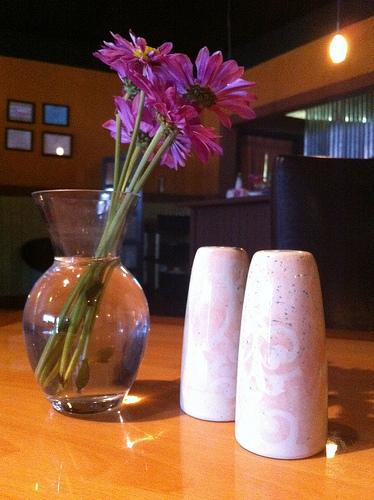List the elements you notice in the image related to the interior design or scenery. Wooden table, clear glass vase, salt and pepper shakers, orange wall, four pictures hanging, and light reflection. In one sentence, tell me what you see in this photograph. A wooden table displays a glass vase with purple flowers and salt and pepper shakers, with four pictures on an orange wall behind. Write a short verse inspired by the scene depicted in this image. Simple beauty, exquisitely expressed. Tell me what the centerpiece of the image consists of. The centerpiece features a glass vase with five purple flowers, green stems, and clear water, placed on a wooden table. Write a brief description of the main items visible in the picture. Purple flowers in a clear vase on a wooden table, salt and pepper shakers, and four pictures hanging on an orange wall. Provide a short narrative describing the scene in the image. In a cozy setting, a wooden table holds a glass vase with beautiful purple flowers, accompanied by salt and pepper shakers, with four pictures adorning the orange wall behind. Mention the objects on the table and their colors. A clear glass vase with purple flowers and green stems, white and gray salt and pepper shakers on a wooden tan table. Describe the composition of the image focusing on the main centerpiece and its surroundings. The centerpiece is a clear vase with purple flowers and green stems, surrounded by salt and pepper shakers, all placed on a reflective wooden table with an orange wall displaying four pictures behind. Mention the objects that could be found at a restaurant in this image. Restaurant table, salt and pepper shakers, clear glass vase with flowers, and light hanging from the ceiling. How many pictures are on the wall, and what color is the wall? There are four pictures on an orange wall. 